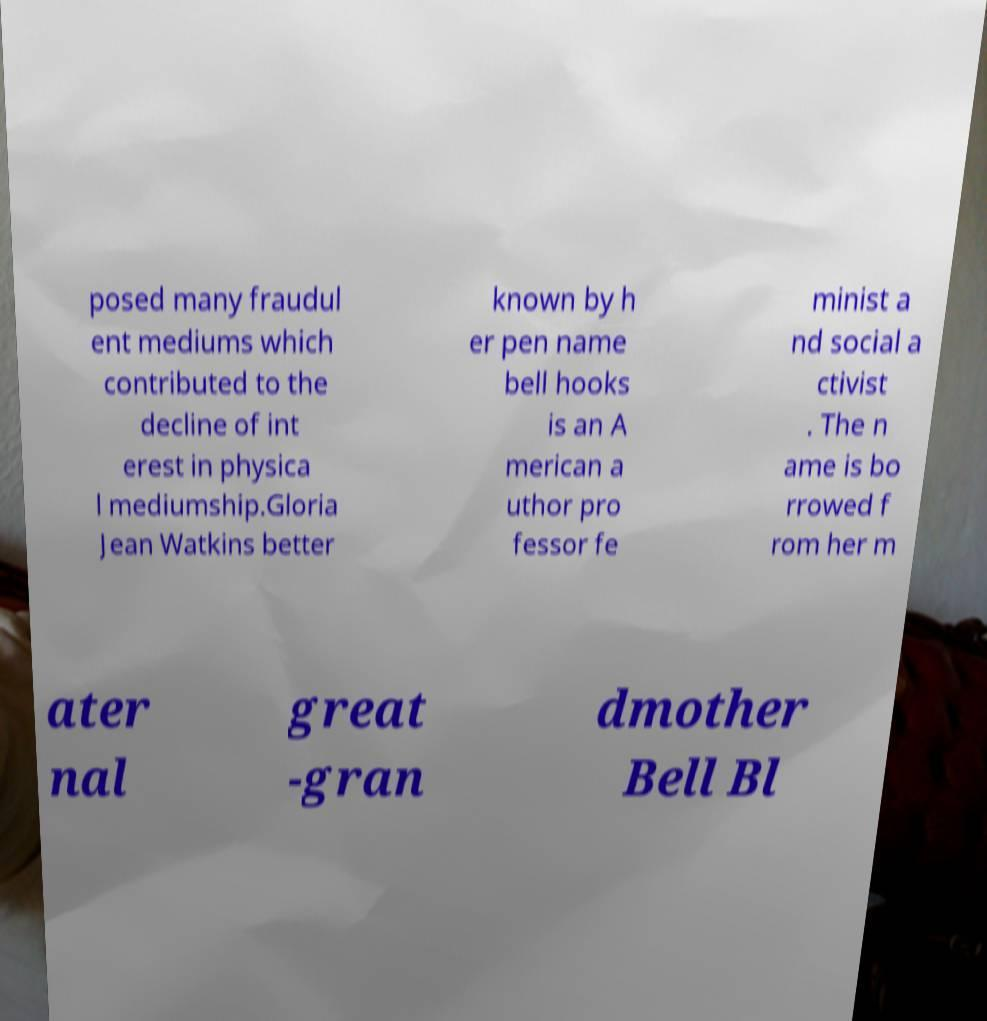I need the written content from this picture converted into text. Can you do that? posed many fraudul ent mediums which contributed to the decline of int erest in physica l mediumship.Gloria Jean Watkins better known by h er pen name bell hooks is an A merican a uthor pro fessor fe minist a nd social a ctivist . The n ame is bo rrowed f rom her m ater nal great -gran dmother Bell Bl 